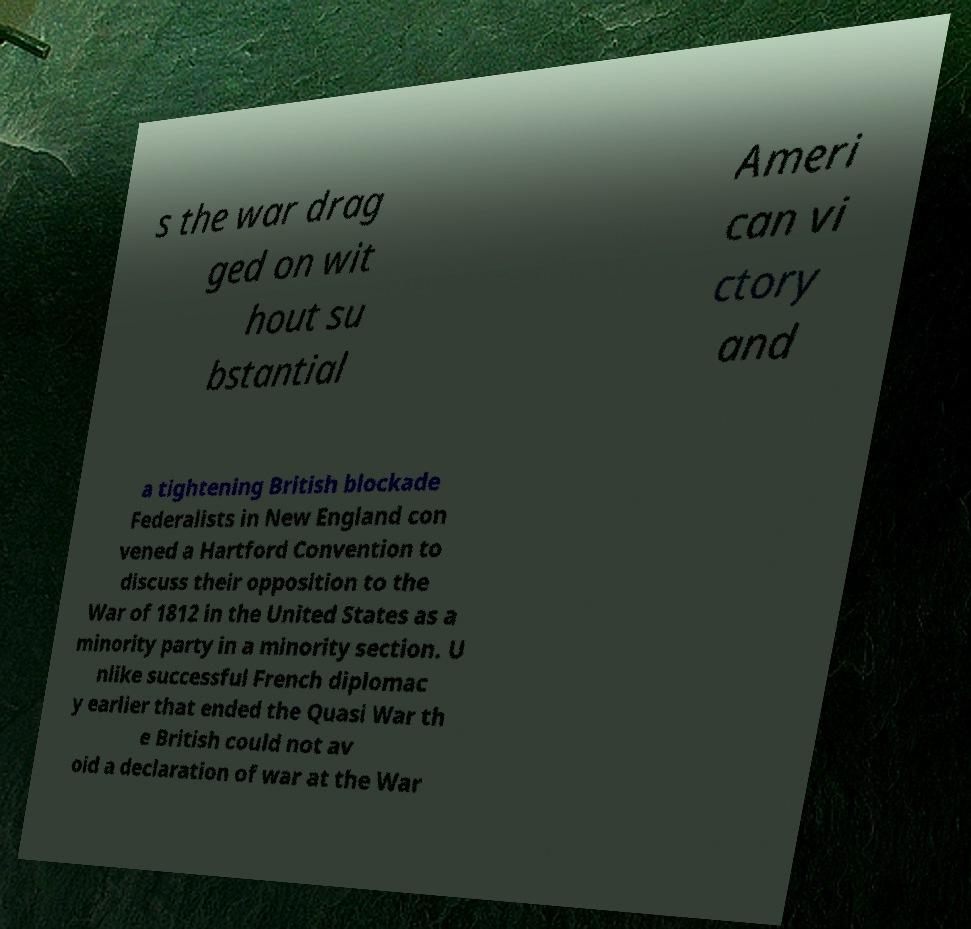Could you assist in decoding the text presented in this image and type it out clearly? s the war drag ged on wit hout su bstantial Ameri can vi ctory and a tightening British blockade Federalists in New England con vened a Hartford Convention to discuss their opposition to the War of 1812 in the United States as a minority party in a minority section. U nlike successful French diplomac y earlier that ended the Quasi War th e British could not av oid a declaration of war at the War 